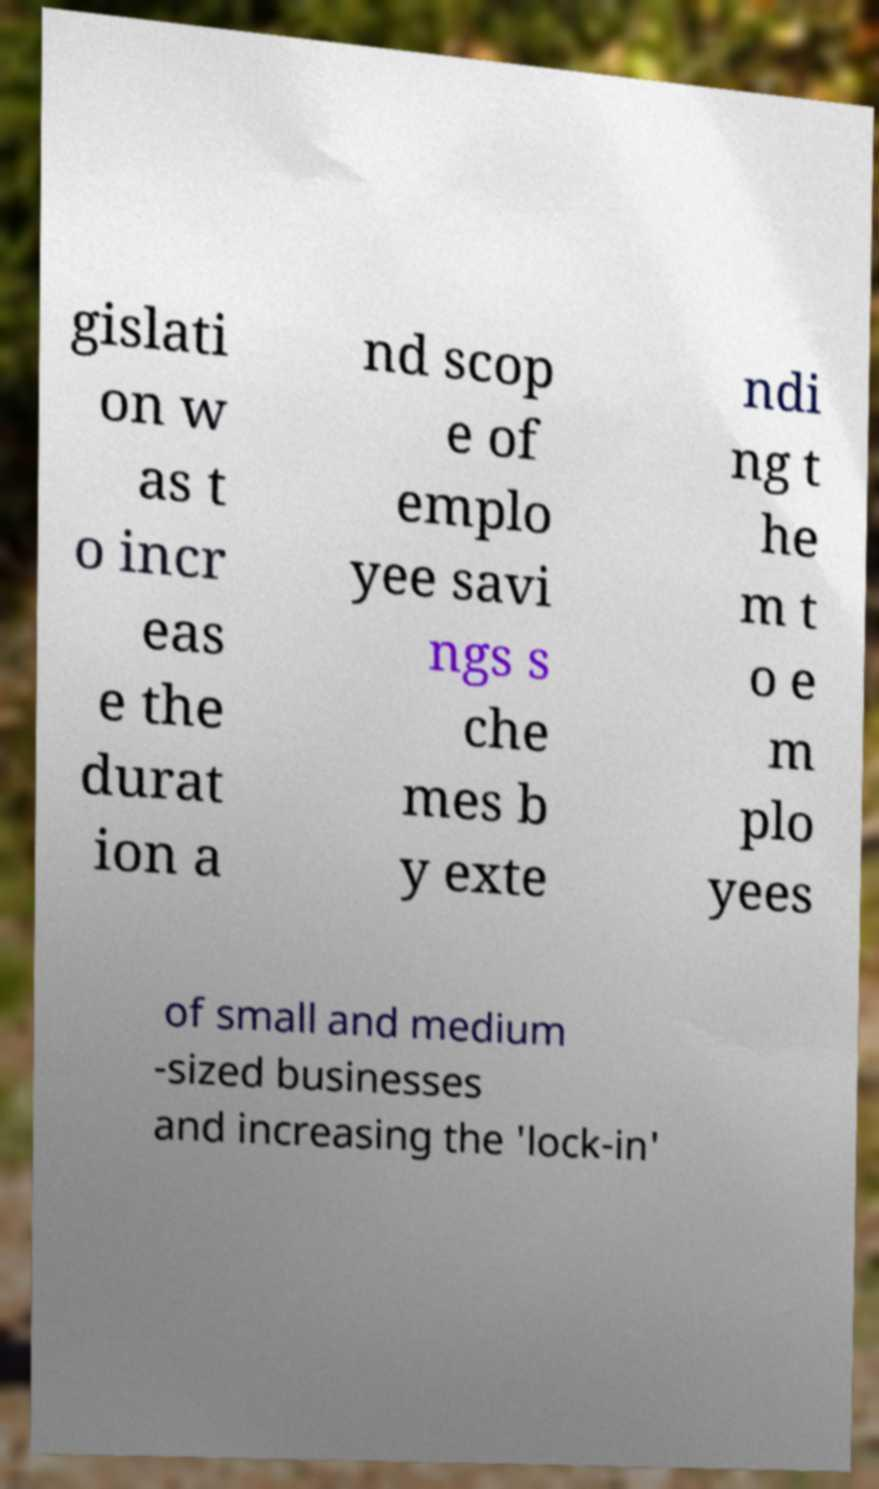Can you read and provide the text displayed in the image?This photo seems to have some interesting text. Can you extract and type it out for me? gislati on w as t o incr eas e the durat ion a nd scop e of emplo yee savi ngs s che mes b y exte ndi ng t he m t o e m plo yees of small and medium -sized businesses and increasing the 'lock-in' 